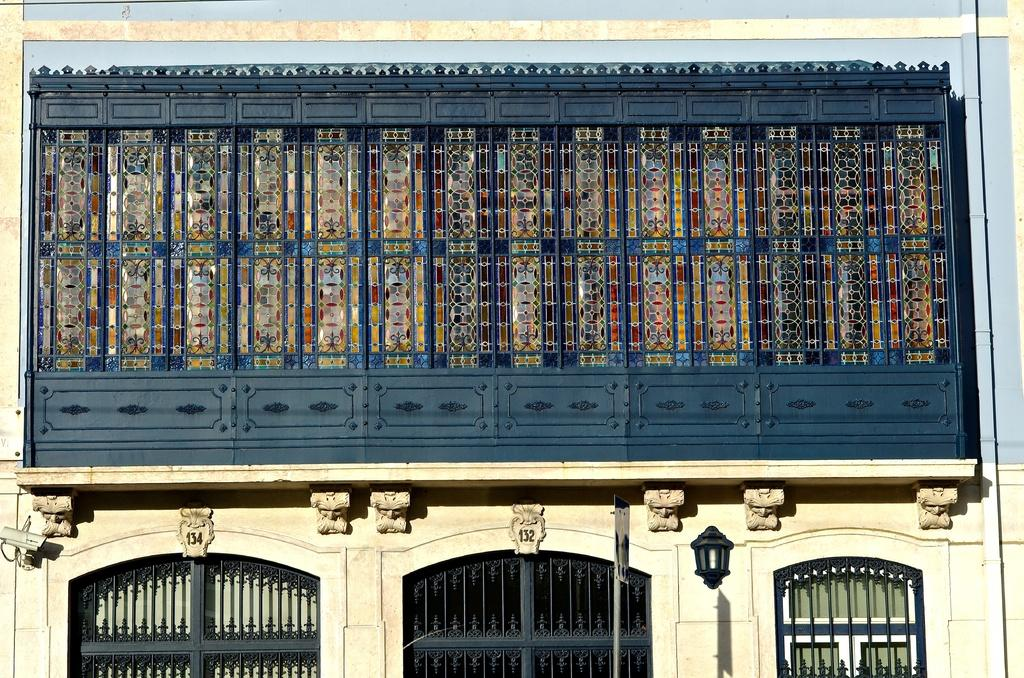What type of structure is visible in the image? There is a building in the image. What specific features can be seen on the building? There are rods and a lantern on the building. Are there any other objects or features on the building? Yes, there are other unspecified things on the building. How does the building react to the slope in the image? There is no slope present in the image, so the building does not react to any slope. 